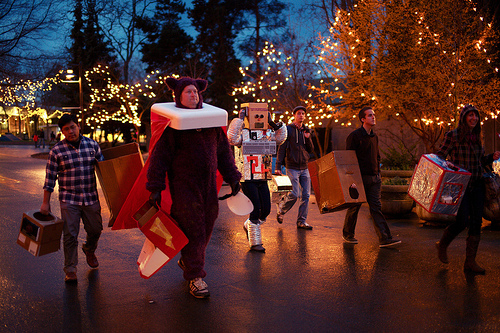<image>
Is there a man in the costume? Yes. The man is contained within or inside the costume, showing a containment relationship. 